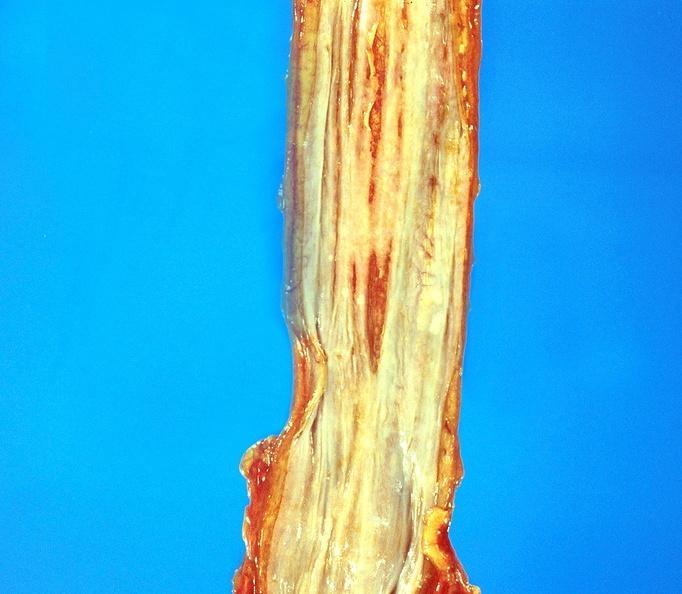s sella present?
Answer the question using a single word or phrase. No 